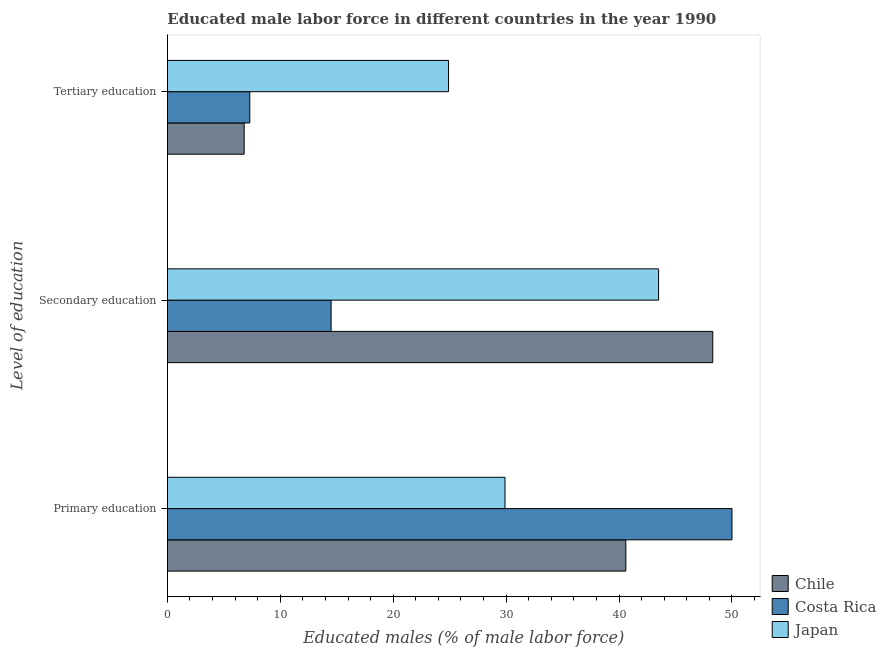How many different coloured bars are there?
Give a very brief answer. 3. How many groups of bars are there?
Offer a terse response. 3. Are the number of bars per tick equal to the number of legend labels?
Your response must be concise. Yes. How many bars are there on the 1st tick from the top?
Your response must be concise. 3. What is the label of the 2nd group of bars from the top?
Offer a very short reply. Secondary education. What is the percentage of male labor force who received tertiary education in Japan?
Make the answer very short. 24.9. Across all countries, what is the maximum percentage of male labor force who received tertiary education?
Provide a succinct answer. 24.9. Across all countries, what is the minimum percentage of male labor force who received secondary education?
Provide a succinct answer. 14.5. In which country was the percentage of male labor force who received primary education maximum?
Give a very brief answer. Costa Rica. What is the total percentage of male labor force who received tertiary education in the graph?
Ensure brevity in your answer.  39. What is the difference between the percentage of male labor force who received tertiary education in Chile and that in Japan?
Your response must be concise. -18.1. What is the difference between the percentage of male labor force who received secondary education in Chile and the percentage of male labor force who received primary education in Costa Rica?
Your answer should be very brief. -1.7. What is the average percentage of male labor force who received primary education per country?
Provide a short and direct response. 40.17. What is the difference between the percentage of male labor force who received primary education and percentage of male labor force who received tertiary education in Costa Rica?
Offer a very short reply. 42.7. What is the ratio of the percentage of male labor force who received secondary education in Chile to that in Costa Rica?
Make the answer very short. 3.33. Is the percentage of male labor force who received secondary education in Japan less than that in Chile?
Provide a succinct answer. Yes. What is the difference between the highest and the second highest percentage of male labor force who received secondary education?
Make the answer very short. 4.8. What is the difference between the highest and the lowest percentage of male labor force who received primary education?
Keep it short and to the point. 20.1. Is the sum of the percentage of male labor force who received primary education in Japan and Costa Rica greater than the maximum percentage of male labor force who received tertiary education across all countries?
Offer a terse response. Yes. What does the 3rd bar from the bottom in Tertiary education represents?
Provide a short and direct response. Japan. Is it the case that in every country, the sum of the percentage of male labor force who received primary education and percentage of male labor force who received secondary education is greater than the percentage of male labor force who received tertiary education?
Give a very brief answer. Yes. How many bars are there?
Offer a very short reply. 9. Are all the bars in the graph horizontal?
Offer a very short reply. Yes. How many countries are there in the graph?
Keep it short and to the point. 3. Does the graph contain any zero values?
Offer a very short reply. No. Where does the legend appear in the graph?
Your answer should be compact. Bottom right. How many legend labels are there?
Keep it short and to the point. 3. What is the title of the graph?
Keep it short and to the point. Educated male labor force in different countries in the year 1990. What is the label or title of the X-axis?
Provide a short and direct response. Educated males (% of male labor force). What is the label or title of the Y-axis?
Make the answer very short. Level of education. What is the Educated males (% of male labor force) in Chile in Primary education?
Give a very brief answer. 40.6. What is the Educated males (% of male labor force) of Japan in Primary education?
Your answer should be very brief. 29.9. What is the Educated males (% of male labor force) of Chile in Secondary education?
Your answer should be compact. 48.3. What is the Educated males (% of male labor force) of Costa Rica in Secondary education?
Offer a very short reply. 14.5. What is the Educated males (% of male labor force) in Japan in Secondary education?
Offer a very short reply. 43.5. What is the Educated males (% of male labor force) in Chile in Tertiary education?
Provide a short and direct response. 6.8. What is the Educated males (% of male labor force) of Costa Rica in Tertiary education?
Offer a terse response. 7.3. What is the Educated males (% of male labor force) of Japan in Tertiary education?
Make the answer very short. 24.9. Across all Level of education, what is the maximum Educated males (% of male labor force) of Chile?
Your answer should be compact. 48.3. Across all Level of education, what is the maximum Educated males (% of male labor force) of Costa Rica?
Make the answer very short. 50. Across all Level of education, what is the maximum Educated males (% of male labor force) in Japan?
Ensure brevity in your answer.  43.5. Across all Level of education, what is the minimum Educated males (% of male labor force) of Chile?
Ensure brevity in your answer.  6.8. Across all Level of education, what is the minimum Educated males (% of male labor force) in Costa Rica?
Ensure brevity in your answer.  7.3. Across all Level of education, what is the minimum Educated males (% of male labor force) of Japan?
Your answer should be compact. 24.9. What is the total Educated males (% of male labor force) of Chile in the graph?
Your answer should be very brief. 95.7. What is the total Educated males (% of male labor force) in Costa Rica in the graph?
Your response must be concise. 71.8. What is the total Educated males (% of male labor force) in Japan in the graph?
Offer a terse response. 98.3. What is the difference between the Educated males (% of male labor force) in Costa Rica in Primary education and that in Secondary education?
Make the answer very short. 35.5. What is the difference between the Educated males (% of male labor force) of Chile in Primary education and that in Tertiary education?
Keep it short and to the point. 33.8. What is the difference between the Educated males (% of male labor force) of Costa Rica in Primary education and that in Tertiary education?
Provide a short and direct response. 42.7. What is the difference between the Educated males (% of male labor force) in Japan in Primary education and that in Tertiary education?
Offer a terse response. 5. What is the difference between the Educated males (% of male labor force) of Chile in Secondary education and that in Tertiary education?
Make the answer very short. 41.5. What is the difference between the Educated males (% of male labor force) in Japan in Secondary education and that in Tertiary education?
Make the answer very short. 18.6. What is the difference between the Educated males (% of male labor force) in Chile in Primary education and the Educated males (% of male labor force) in Costa Rica in Secondary education?
Give a very brief answer. 26.1. What is the difference between the Educated males (% of male labor force) of Chile in Primary education and the Educated males (% of male labor force) of Costa Rica in Tertiary education?
Ensure brevity in your answer.  33.3. What is the difference between the Educated males (% of male labor force) of Costa Rica in Primary education and the Educated males (% of male labor force) of Japan in Tertiary education?
Provide a short and direct response. 25.1. What is the difference between the Educated males (% of male labor force) of Chile in Secondary education and the Educated males (% of male labor force) of Japan in Tertiary education?
Give a very brief answer. 23.4. What is the difference between the Educated males (% of male labor force) in Costa Rica in Secondary education and the Educated males (% of male labor force) in Japan in Tertiary education?
Give a very brief answer. -10.4. What is the average Educated males (% of male labor force) of Chile per Level of education?
Keep it short and to the point. 31.9. What is the average Educated males (% of male labor force) in Costa Rica per Level of education?
Offer a terse response. 23.93. What is the average Educated males (% of male labor force) of Japan per Level of education?
Keep it short and to the point. 32.77. What is the difference between the Educated males (% of male labor force) in Chile and Educated males (% of male labor force) in Costa Rica in Primary education?
Provide a succinct answer. -9.4. What is the difference between the Educated males (% of male labor force) in Chile and Educated males (% of male labor force) in Japan in Primary education?
Provide a succinct answer. 10.7. What is the difference between the Educated males (% of male labor force) of Costa Rica and Educated males (% of male labor force) of Japan in Primary education?
Keep it short and to the point. 20.1. What is the difference between the Educated males (% of male labor force) of Chile and Educated males (% of male labor force) of Costa Rica in Secondary education?
Your answer should be compact. 33.8. What is the difference between the Educated males (% of male labor force) of Costa Rica and Educated males (% of male labor force) of Japan in Secondary education?
Your answer should be very brief. -29. What is the difference between the Educated males (% of male labor force) in Chile and Educated males (% of male labor force) in Costa Rica in Tertiary education?
Provide a short and direct response. -0.5. What is the difference between the Educated males (% of male labor force) in Chile and Educated males (% of male labor force) in Japan in Tertiary education?
Provide a succinct answer. -18.1. What is the difference between the Educated males (% of male labor force) in Costa Rica and Educated males (% of male labor force) in Japan in Tertiary education?
Provide a short and direct response. -17.6. What is the ratio of the Educated males (% of male labor force) in Chile in Primary education to that in Secondary education?
Your answer should be compact. 0.84. What is the ratio of the Educated males (% of male labor force) in Costa Rica in Primary education to that in Secondary education?
Give a very brief answer. 3.45. What is the ratio of the Educated males (% of male labor force) of Japan in Primary education to that in Secondary education?
Keep it short and to the point. 0.69. What is the ratio of the Educated males (% of male labor force) in Chile in Primary education to that in Tertiary education?
Your answer should be very brief. 5.97. What is the ratio of the Educated males (% of male labor force) of Costa Rica in Primary education to that in Tertiary education?
Offer a terse response. 6.85. What is the ratio of the Educated males (% of male labor force) in Japan in Primary education to that in Tertiary education?
Give a very brief answer. 1.2. What is the ratio of the Educated males (% of male labor force) in Chile in Secondary education to that in Tertiary education?
Offer a terse response. 7.1. What is the ratio of the Educated males (% of male labor force) of Costa Rica in Secondary education to that in Tertiary education?
Offer a terse response. 1.99. What is the ratio of the Educated males (% of male labor force) in Japan in Secondary education to that in Tertiary education?
Provide a succinct answer. 1.75. What is the difference between the highest and the second highest Educated males (% of male labor force) in Chile?
Offer a very short reply. 7.7. What is the difference between the highest and the second highest Educated males (% of male labor force) in Costa Rica?
Offer a terse response. 35.5. What is the difference between the highest and the second highest Educated males (% of male labor force) of Japan?
Provide a succinct answer. 13.6. What is the difference between the highest and the lowest Educated males (% of male labor force) of Chile?
Your answer should be very brief. 41.5. What is the difference between the highest and the lowest Educated males (% of male labor force) in Costa Rica?
Make the answer very short. 42.7. What is the difference between the highest and the lowest Educated males (% of male labor force) of Japan?
Your answer should be very brief. 18.6. 